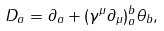<formula> <loc_0><loc_0><loc_500><loc_500>D _ { a } = \partial _ { a } + ( \gamma ^ { \mu } \partial _ { \mu } ) ^ { b } _ { a } \theta _ { b } ,</formula> 